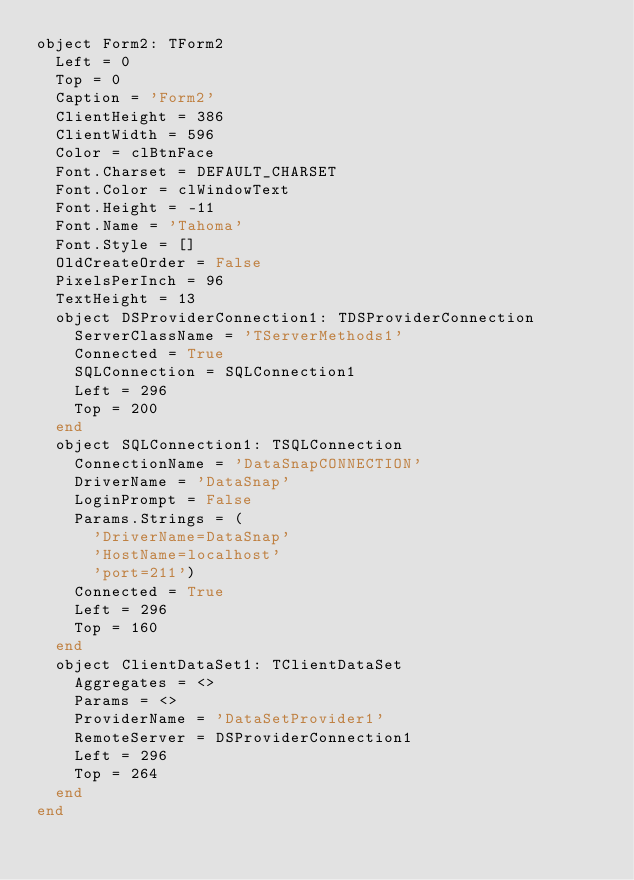Convert code to text. <code><loc_0><loc_0><loc_500><loc_500><_Pascal_>object Form2: TForm2
  Left = 0
  Top = 0
  Caption = 'Form2'
  ClientHeight = 386
  ClientWidth = 596
  Color = clBtnFace
  Font.Charset = DEFAULT_CHARSET
  Font.Color = clWindowText
  Font.Height = -11
  Font.Name = 'Tahoma'
  Font.Style = []
  OldCreateOrder = False
  PixelsPerInch = 96
  TextHeight = 13
  object DSProviderConnection1: TDSProviderConnection
    ServerClassName = 'TServerMethods1'
    Connected = True
    SQLConnection = SQLConnection1
    Left = 296
    Top = 200
  end
  object SQLConnection1: TSQLConnection
    ConnectionName = 'DataSnapCONNECTION'
    DriverName = 'DataSnap'
    LoginPrompt = False
    Params.Strings = (
      'DriverName=DataSnap'
      'HostName=localhost'
      'port=211')
    Connected = True
    Left = 296
    Top = 160
  end
  object ClientDataSet1: TClientDataSet
    Aggregates = <>
    Params = <>
    ProviderName = 'DataSetProvider1'
    RemoteServer = DSProviderConnection1
    Left = 296
    Top = 264
  end
end
</code> 